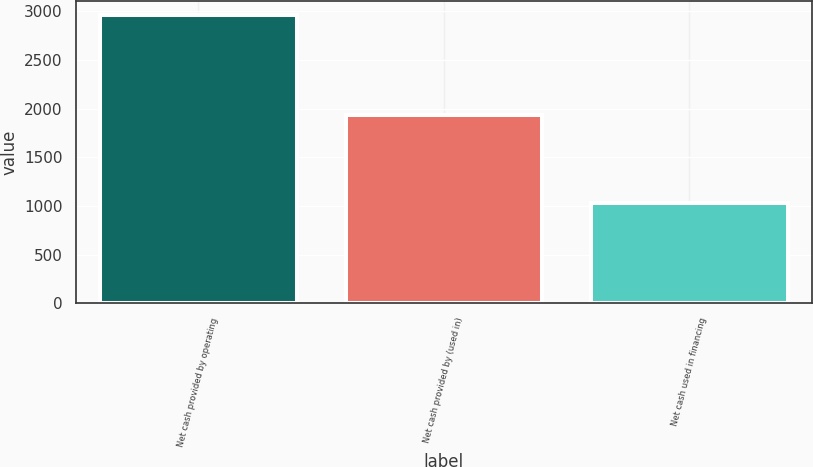Convert chart. <chart><loc_0><loc_0><loc_500><loc_500><bar_chart><fcel>Net cash provided by operating<fcel>Net cash provided by (used in)<fcel>Net cash used in financing<nl><fcel>2960<fcel>1932<fcel>1035<nl></chart> 